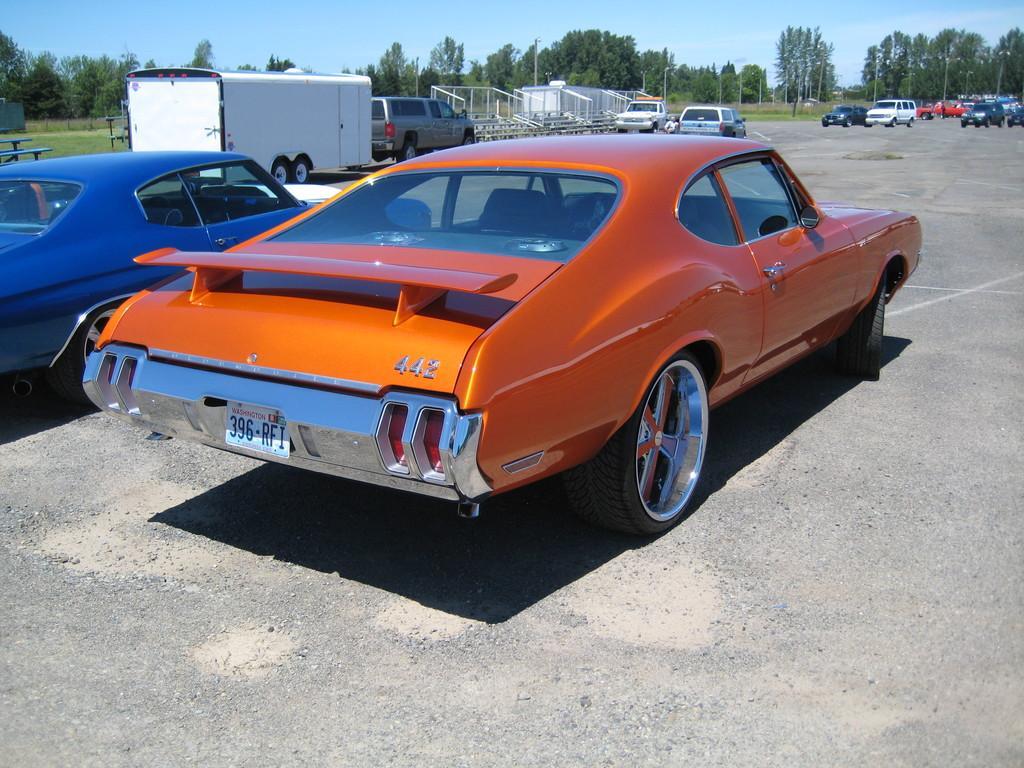Please provide a concise description of this image. This is an outside view. Here I can see many vehicles on the road. In the background there is a shed and many trees and also I can see the poles. At the top of the image I can see the sky. 